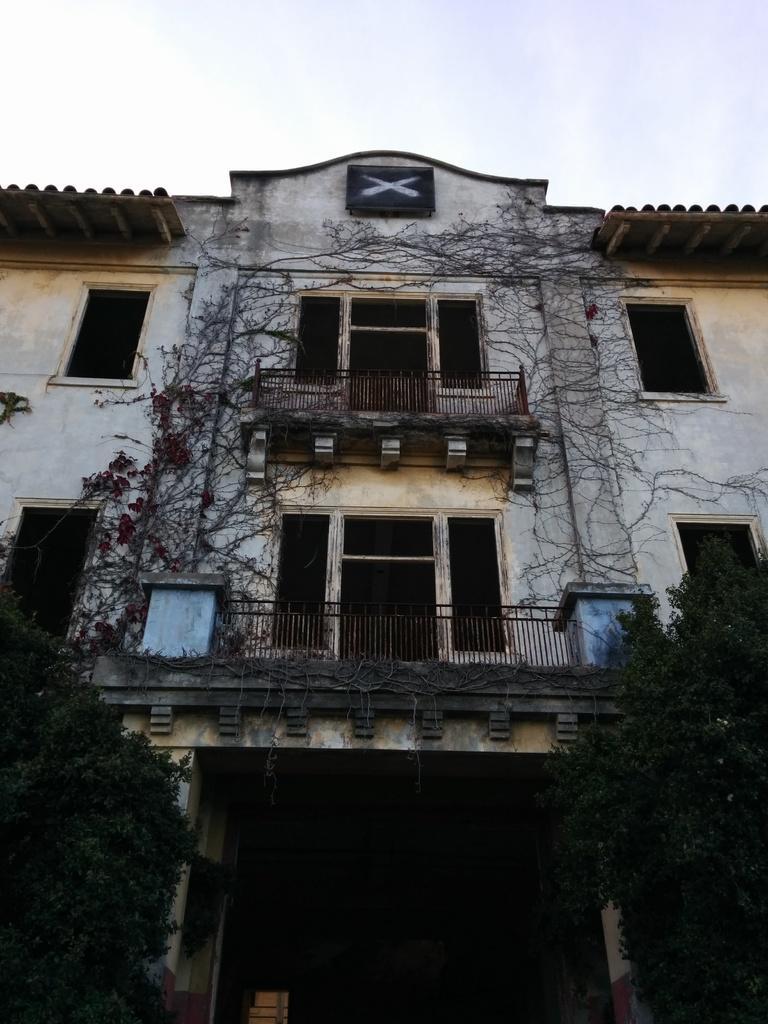In one or two sentences, can you explain what this image depicts? In this image we can see a building, creepers, iron grills, trees, shed and sky. 